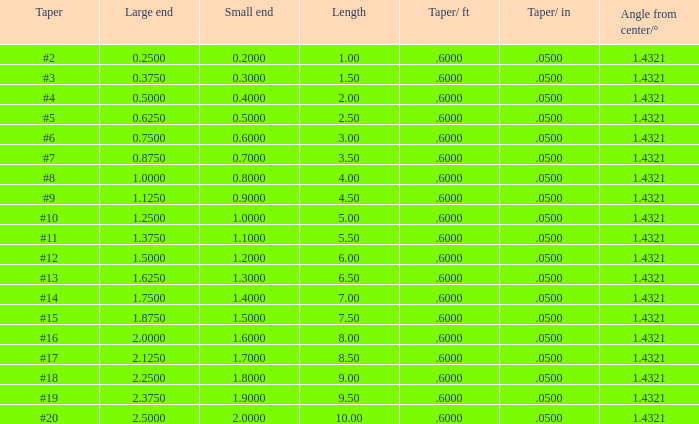Can you parse all the data within this table? {'header': ['Taper', 'Large end', 'Small end', 'Length', 'Taper/ ft', 'Taper/ in', 'Angle from center/°'], 'rows': [['#2', '0.2500', '0.2000', '1.00', '.6000', '.0500', '1.4321'], ['#3', '0.3750', '0.3000', '1.50', '.6000', '.0500', '1.4321'], ['#4', '0.5000', '0.4000', '2.00', '.6000', '.0500', '1.4321'], ['#5', '0.6250', '0.5000', '2.50', '.6000', '.0500', '1.4321'], ['#6', '0.7500', '0.6000', '3.00', '.6000', '.0500', '1.4321'], ['#7', '0.8750', '0.7000', '3.50', '.6000', '.0500', '1.4321'], ['#8', '1.0000', '0.8000', '4.00', '.6000', '.0500', '1.4321'], ['#9', '1.1250', '0.9000', '4.50', '.6000', '.0500', '1.4321'], ['#10', '1.2500', '1.0000', '5.00', '.6000', '.0500', '1.4321'], ['#11', '1.3750', '1.1000', '5.50', '.6000', '.0500', '1.4321'], ['#12', '1.5000', '1.2000', '6.00', '.6000', '.0500', '1.4321'], ['#13', '1.6250', '1.3000', '6.50', '.6000', '.0500', '1.4321'], ['#14', '1.7500', '1.4000', '7.00', '.6000', '.0500', '1.4321'], ['#15', '1.8750', '1.5000', '7.50', '.6000', '.0500', '1.4321'], ['#16', '2.0000', '1.6000', '8.00', '.6000', '.0500', '1.4321'], ['#17', '2.1250', '1.7000', '8.50', '.6000', '.0500', '1.4321'], ['#18', '2.2500', '1.8000', '9.00', '.6000', '.0500', '1.4321'], ['#19', '2.3750', '1.9000', '9.50', '.6000', '.0500', '1.4321'], ['#20', '2.5000', '2.0000', '10.00', '.6000', '.0500', '1.4321']]} Which Length has a Taper of #15, and a Large end larger than 1.875? None. 